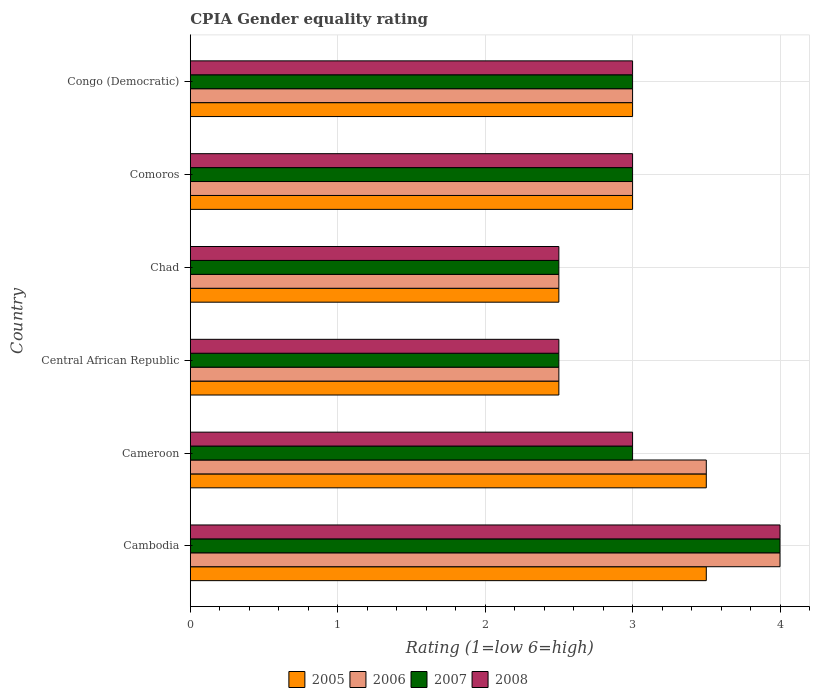How many different coloured bars are there?
Keep it short and to the point. 4. Are the number of bars on each tick of the Y-axis equal?
Make the answer very short. Yes. How many bars are there on the 4th tick from the top?
Ensure brevity in your answer.  4. What is the label of the 1st group of bars from the top?
Give a very brief answer. Congo (Democratic). In how many cases, is the number of bars for a given country not equal to the number of legend labels?
Give a very brief answer. 0. What is the CPIA rating in 2008 in Central African Republic?
Offer a very short reply. 2.5. Across all countries, what is the maximum CPIA rating in 2006?
Offer a very short reply. 4. In which country was the CPIA rating in 2007 maximum?
Provide a succinct answer. Cambodia. In which country was the CPIA rating in 2007 minimum?
Your response must be concise. Central African Republic. What is the total CPIA rating in 2006 in the graph?
Offer a very short reply. 18.5. What is the average CPIA rating in 2007 per country?
Provide a succinct answer. 3. What is the ratio of the CPIA rating in 2005 in Cambodia to that in Central African Republic?
Make the answer very short. 1.4. Is the difference between the CPIA rating in 2006 in Cambodia and Congo (Democratic) greater than the difference between the CPIA rating in 2005 in Cambodia and Congo (Democratic)?
Your answer should be compact. Yes. What is the difference between the highest and the second highest CPIA rating in 2005?
Ensure brevity in your answer.  0. What is the difference between the highest and the lowest CPIA rating in 2006?
Ensure brevity in your answer.  1.5. In how many countries, is the CPIA rating in 2005 greater than the average CPIA rating in 2005 taken over all countries?
Offer a terse response. 2. Is it the case that in every country, the sum of the CPIA rating in 2008 and CPIA rating in 2005 is greater than the CPIA rating in 2007?
Make the answer very short. Yes. How many bars are there?
Offer a terse response. 24. Are all the bars in the graph horizontal?
Offer a terse response. Yes. Are the values on the major ticks of X-axis written in scientific E-notation?
Ensure brevity in your answer.  No. Does the graph contain grids?
Your answer should be very brief. Yes. Where does the legend appear in the graph?
Make the answer very short. Bottom center. What is the title of the graph?
Offer a terse response. CPIA Gender equality rating. What is the label or title of the X-axis?
Your answer should be very brief. Rating (1=low 6=high). What is the label or title of the Y-axis?
Provide a succinct answer. Country. What is the Rating (1=low 6=high) of 2007 in Cambodia?
Your response must be concise. 4. What is the Rating (1=low 6=high) of 2008 in Cambodia?
Ensure brevity in your answer.  4. What is the Rating (1=low 6=high) of 2005 in Cameroon?
Provide a succinct answer. 3.5. What is the Rating (1=low 6=high) of 2008 in Cameroon?
Make the answer very short. 3. What is the Rating (1=low 6=high) of 2005 in Central African Republic?
Provide a short and direct response. 2.5. What is the Rating (1=low 6=high) of 2006 in Central African Republic?
Your answer should be compact. 2.5. What is the Rating (1=low 6=high) in 2005 in Chad?
Your answer should be compact. 2.5. What is the Rating (1=low 6=high) in 2008 in Chad?
Offer a terse response. 2.5. What is the Rating (1=low 6=high) of 2006 in Comoros?
Offer a terse response. 3. What is the Rating (1=low 6=high) of 2008 in Comoros?
Offer a very short reply. 3. What is the Rating (1=low 6=high) in 2005 in Congo (Democratic)?
Your response must be concise. 3. What is the Rating (1=low 6=high) in 2007 in Congo (Democratic)?
Ensure brevity in your answer.  3. What is the Rating (1=low 6=high) in 2008 in Congo (Democratic)?
Your response must be concise. 3. Across all countries, what is the maximum Rating (1=low 6=high) in 2005?
Make the answer very short. 3.5. Across all countries, what is the maximum Rating (1=low 6=high) in 2007?
Keep it short and to the point. 4. Across all countries, what is the maximum Rating (1=low 6=high) in 2008?
Your answer should be very brief. 4. Across all countries, what is the minimum Rating (1=low 6=high) of 2005?
Offer a very short reply. 2.5. Across all countries, what is the minimum Rating (1=low 6=high) of 2007?
Ensure brevity in your answer.  2.5. Across all countries, what is the minimum Rating (1=low 6=high) of 2008?
Your response must be concise. 2.5. What is the total Rating (1=low 6=high) of 2005 in the graph?
Your answer should be very brief. 18. What is the difference between the Rating (1=low 6=high) of 2006 in Cambodia and that in Cameroon?
Offer a terse response. 0.5. What is the difference between the Rating (1=low 6=high) of 2007 in Cambodia and that in Cameroon?
Provide a short and direct response. 1. What is the difference between the Rating (1=low 6=high) in 2008 in Cambodia and that in Cameroon?
Your answer should be compact. 1. What is the difference between the Rating (1=low 6=high) in 2005 in Cambodia and that in Central African Republic?
Your answer should be compact. 1. What is the difference between the Rating (1=low 6=high) of 2006 in Cambodia and that in Central African Republic?
Provide a succinct answer. 1.5. What is the difference between the Rating (1=low 6=high) of 2006 in Cambodia and that in Chad?
Provide a short and direct response. 1.5. What is the difference between the Rating (1=low 6=high) in 2007 in Cambodia and that in Chad?
Your response must be concise. 1.5. What is the difference between the Rating (1=low 6=high) in 2005 in Cambodia and that in Comoros?
Provide a succinct answer. 0.5. What is the difference between the Rating (1=low 6=high) of 2006 in Cambodia and that in Comoros?
Provide a succinct answer. 1. What is the difference between the Rating (1=low 6=high) of 2008 in Cambodia and that in Comoros?
Give a very brief answer. 1. What is the difference between the Rating (1=low 6=high) in 2007 in Cambodia and that in Congo (Democratic)?
Offer a very short reply. 1. What is the difference between the Rating (1=low 6=high) in 2005 in Cameroon and that in Chad?
Your answer should be very brief. 1. What is the difference between the Rating (1=low 6=high) in 2006 in Cameroon and that in Chad?
Offer a terse response. 1. What is the difference between the Rating (1=low 6=high) in 2007 in Cameroon and that in Chad?
Your response must be concise. 0.5. What is the difference between the Rating (1=low 6=high) in 2008 in Cameroon and that in Chad?
Your response must be concise. 0.5. What is the difference between the Rating (1=low 6=high) in 2006 in Cameroon and that in Comoros?
Make the answer very short. 0.5. What is the difference between the Rating (1=low 6=high) of 2005 in Cameroon and that in Congo (Democratic)?
Offer a terse response. 0.5. What is the difference between the Rating (1=low 6=high) of 2006 in Cameroon and that in Congo (Democratic)?
Your answer should be very brief. 0.5. What is the difference between the Rating (1=low 6=high) of 2007 in Cameroon and that in Congo (Democratic)?
Give a very brief answer. 0. What is the difference between the Rating (1=low 6=high) in 2008 in Cameroon and that in Congo (Democratic)?
Your answer should be very brief. 0. What is the difference between the Rating (1=low 6=high) of 2006 in Central African Republic and that in Chad?
Your answer should be very brief. 0. What is the difference between the Rating (1=low 6=high) in 2007 in Central African Republic and that in Chad?
Your answer should be very brief. 0. What is the difference between the Rating (1=low 6=high) of 2006 in Central African Republic and that in Comoros?
Offer a very short reply. -0.5. What is the difference between the Rating (1=low 6=high) of 2007 in Central African Republic and that in Comoros?
Give a very brief answer. -0.5. What is the difference between the Rating (1=low 6=high) of 2008 in Central African Republic and that in Comoros?
Offer a very short reply. -0.5. What is the difference between the Rating (1=low 6=high) in 2005 in Central African Republic and that in Congo (Democratic)?
Offer a terse response. -0.5. What is the difference between the Rating (1=low 6=high) in 2006 in Central African Republic and that in Congo (Democratic)?
Give a very brief answer. -0.5. What is the difference between the Rating (1=low 6=high) of 2007 in Central African Republic and that in Congo (Democratic)?
Your answer should be very brief. -0.5. What is the difference between the Rating (1=low 6=high) of 2007 in Chad and that in Comoros?
Make the answer very short. -0.5. What is the difference between the Rating (1=low 6=high) of 2005 in Comoros and that in Congo (Democratic)?
Ensure brevity in your answer.  0. What is the difference between the Rating (1=low 6=high) in 2006 in Comoros and that in Congo (Democratic)?
Offer a very short reply. 0. What is the difference between the Rating (1=low 6=high) of 2007 in Comoros and that in Congo (Democratic)?
Ensure brevity in your answer.  0. What is the difference between the Rating (1=low 6=high) of 2008 in Comoros and that in Congo (Democratic)?
Keep it short and to the point. 0. What is the difference between the Rating (1=low 6=high) of 2005 in Cambodia and the Rating (1=low 6=high) of 2006 in Cameroon?
Your answer should be very brief. 0. What is the difference between the Rating (1=low 6=high) of 2005 in Cambodia and the Rating (1=low 6=high) of 2007 in Cameroon?
Ensure brevity in your answer.  0.5. What is the difference between the Rating (1=low 6=high) in 2005 in Cambodia and the Rating (1=low 6=high) in 2008 in Cameroon?
Your response must be concise. 0.5. What is the difference between the Rating (1=low 6=high) in 2006 in Cambodia and the Rating (1=low 6=high) in 2007 in Cameroon?
Make the answer very short. 1. What is the difference between the Rating (1=low 6=high) of 2006 in Cambodia and the Rating (1=low 6=high) of 2008 in Cameroon?
Ensure brevity in your answer.  1. What is the difference between the Rating (1=low 6=high) in 2005 in Cambodia and the Rating (1=low 6=high) in 2006 in Central African Republic?
Your answer should be compact. 1. What is the difference between the Rating (1=low 6=high) of 2005 in Cambodia and the Rating (1=low 6=high) of 2007 in Chad?
Make the answer very short. 1. What is the difference between the Rating (1=low 6=high) of 2005 in Cambodia and the Rating (1=low 6=high) of 2008 in Chad?
Your answer should be compact. 1. What is the difference between the Rating (1=low 6=high) of 2006 in Cambodia and the Rating (1=low 6=high) of 2007 in Chad?
Keep it short and to the point. 1.5. What is the difference between the Rating (1=low 6=high) in 2007 in Cambodia and the Rating (1=low 6=high) in 2008 in Chad?
Offer a terse response. 1.5. What is the difference between the Rating (1=low 6=high) in 2005 in Cambodia and the Rating (1=low 6=high) in 2006 in Comoros?
Offer a terse response. 0.5. What is the difference between the Rating (1=low 6=high) of 2005 in Cambodia and the Rating (1=low 6=high) of 2008 in Comoros?
Provide a short and direct response. 0.5. What is the difference between the Rating (1=low 6=high) of 2005 in Cambodia and the Rating (1=low 6=high) of 2006 in Congo (Democratic)?
Keep it short and to the point. 0.5. What is the difference between the Rating (1=low 6=high) in 2005 in Cambodia and the Rating (1=low 6=high) in 2007 in Congo (Democratic)?
Your answer should be very brief. 0.5. What is the difference between the Rating (1=low 6=high) in 2006 in Cambodia and the Rating (1=low 6=high) in 2008 in Congo (Democratic)?
Provide a short and direct response. 1. What is the difference between the Rating (1=low 6=high) in 2005 in Cameroon and the Rating (1=low 6=high) in 2006 in Central African Republic?
Offer a very short reply. 1. What is the difference between the Rating (1=low 6=high) in 2005 in Cameroon and the Rating (1=low 6=high) in 2007 in Central African Republic?
Provide a short and direct response. 1. What is the difference between the Rating (1=low 6=high) of 2005 in Cameroon and the Rating (1=low 6=high) of 2008 in Central African Republic?
Ensure brevity in your answer.  1. What is the difference between the Rating (1=low 6=high) of 2005 in Cameroon and the Rating (1=low 6=high) of 2007 in Chad?
Make the answer very short. 1. What is the difference between the Rating (1=low 6=high) in 2006 in Cameroon and the Rating (1=low 6=high) in 2008 in Chad?
Offer a terse response. 1. What is the difference between the Rating (1=low 6=high) of 2007 in Cameroon and the Rating (1=low 6=high) of 2008 in Chad?
Ensure brevity in your answer.  0.5. What is the difference between the Rating (1=low 6=high) of 2005 in Cameroon and the Rating (1=low 6=high) of 2006 in Comoros?
Offer a very short reply. 0.5. What is the difference between the Rating (1=low 6=high) in 2005 in Cameroon and the Rating (1=low 6=high) in 2008 in Comoros?
Make the answer very short. 0.5. What is the difference between the Rating (1=low 6=high) in 2006 in Cameroon and the Rating (1=low 6=high) in 2007 in Comoros?
Give a very brief answer. 0.5. What is the difference between the Rating (1=low 6=high) of 2006 in Cameroon and the Rating (1=low 6=high) of 2008 in Comoros?
Give a very brief answer. 0.5. What is the difference between the Rating (1=low 6=high) of 2007 in Cameroon and the Rating (1=low 6=high) of 2008 in Comoros?
Provide a short and direct response. 0. What is the difference between the Rating (1=low 6=high) of 2005 in Cameroon and the Rating (1=low 6=high) of 2006 in Congo (Democratic)?
Your answer should be very brief. 0.5. What is the difference between the Rating (1=low 6=high) in 2005 in Cameroon and the Rating (1=low 6=high) in 2008 in Congo (Democratic)?
Your answer should be very brief. 0.5. What is the difference between the Rating (1=low 6=high) in 2005 in Central African Republic and the Rating (1=low 6=high) in 2008 in Chad?
Ensure brevity in your answer.  0. What is the difference between the Rating (1=low 6=high) of 2006 in Central African Republic and the Rating (1=low 6=high) of 2007 in Chad?
Give a very brief answer. 0. What is the difference between the Rating (1=low 6=high) of 2007 in Central African Republic and the Rating (1=low 6=high) of 2008 in Chad?
Your answer should be very brief. 0. What is the difference between the Rating (1=low 6=high) in 2005 in Central African Republic and the Rating (1=low 6=high) in 2006 in Comoros?
Your answer should be very brief. -0.5. What is the difference between the Rating (1=low 6=high) in 2005 in Central African Republic and the Rating (1=low 6=high) in 2007 in Comoros?
Offer a very short reply. -0.5. What is the difference between the Rating (1=low 6=high) in 2006 in Central African Republic and the Rating (1=low 6=high) in 2008 in Comoros?
Give a very brief answer. -0.5. What is the difference between the Rating (1=low 6=high) of 2007 in Central African Republic and the Rating (1=low 6=high) of 2008 in Comoros?
Give a very brief answer. -0.5. What is the difference between the Rating (1=low 6=high) of 2005 in Central African Republic and the Rating (1=low 6=high) of 2006 in Congo (Democratic)?
Keep it short and to the point. -0.5. What is the difference between the Rating (1=low 6=high) of 2006 in Central African Republic and the Rating (1=low 6=high) of 2007 in Congo (Democratic)?
Provide a short and direct response. -0.5. What is the difference between the Rating (1=low 6=high) of 2006 in Central African Republic and the Rating (1=low 6=high) of 2008 in Congo (Democratic)?
Provide a short and direct response. -0.5. What is the difference between the Rating (1=low 6=high) in 2005 in Chad and the Rating (1=low 6=high) in 2006 in Comoros?
Ensure brevity in your answer.  -0.5. What is the difference between the Rating (1=low 6=high) in 2005 in Chad and the Rating (1=low 6=high) in 2008 in Comoros?
Your answer should be very brief. -0.5. What is the difference between the Rating (1=low 6=high) in 2006 in Chad and the Rating (1=low 6=high) in 2008 in Comoros?
Your answer should be compact. -0.5. What is the difference between the Rating (1=low 6=high) of 2007 in Chad and the Rating (1=low 6=high) of 2008 in Congo (Democratic)?
Ensure brevity in your answer.  -0.5. What is the difference between the Rating (1=low 6=high) in 2005 in Comoros and the Rating (1=low 6=high) in 2007 in Congo (Democratic)?
Provide a short and direct response. 0. What is the difference between the Rating (1=low 6=high) of 2005 in Comoros and the Rating (1=low 6=high) of 2008 in Congo (Democratic)?
Provide a short and direct response. 0. What is the difference between the Rating (1=low 6=high) of 2006 in Comoros and the Rating (1=low 6=high) of 2007 in Congo (Democratic)?
Keep it short and to the point. 0. What is the difference between the Rating (1=low 6=high) of 2007 in Comoros and the Rating (1=low 6=high) of 2008 in Congo (Democratic)?
Your answer should be very brief. 0. What is the average Rating (1=low 6=high) in 2005 per country?
Provide a succinct answer. 3. What is the average Rating (1=low 6=high) in 2006 per country?
Provide a succinct answer. 3.08. What is the average Rating (1=low 6=high) of 2007 per country?
Keep it short and to the point. 3. What is the difference between the Rating (1=low 6=high) in 2005 and Rating (1=low 6=high) in 2006 in Cambodia?
Provide a succinct answer. -0.5. What is the difference between the Rating (1=low 6=high) of 2005 and Rating (1=low 6=high) of 2007 in Cambodia?
Your answer should be compact. -0.5. What is the difference between the Rating (1=low 6=high) in 2005 and Rating (1=low 6=high) in 2008 in Cambodia?
Ensure brevity in your answer.  -0.5. What is the difference between the Rating (1=low 6=high) of 2006 and Rating (1=low 6=high) of 2007 in Cambodia?
Your response must be concise. 0. What is the difference between the Rating (1=low 6=high) of 2006 and Rating (1=low 6=high) of 2008 in Cambodia?
Keep it short and to the point. 0. What is the difference between the Rating (1=low 6=high) of 2007 and Rating (1=low 6=high) of 2008 in Cambodia?
Offer a terse response. 0. What is the difference between the Rating (1=low 6=high) of 2005 and Rating (1=low 6=high) of 2008 in Cameroon?
Keep it short and to the point. 0.5. What is the difference between the Rating (1=low 6=high) of 2006 and Rating (1=low 6=high) of 2008 in Cameroon?
Offer a very short reply. 0.5. What is the difference between the Rating (1=low 6=high) in 2007 and Rating (1=low 6=high) in 2008 in Cameroon?
Give a very brief answer. 0. What is the difference between the Rating (1=low 6=high) in 2005 and Rating (1=low 6=high) in 2008 in Central African Republic?
Your answer should be compact. 0. What is the difference between the Rating (1=low 6=high) of 2006 and Rating (1=low 6=high) of 2007 in Central African Republic?
Keep it short and to the point. 0. What is the difference between the Rating (1=low 6=high) of 2005 and Rating (1=low 6=high) of 2008 in Chad?
Provide a succinct answer. 0. What is the difference between the Rating (1=low 6=high) in 2006 and Rating (1=low 6=high) in 2007 in Chad?
Your answer should be very brief. 0. What is the difference between the Rating (1=low 6=high) of 2006 and Rating (1=low 6=high) of 2008 in Chad?
Offer a terse response. 0. What is the difference between the Rating (1=low 6=high) of 2007 and Rating (1=low 6=high) of 2008 in Chad?
Your answer should be very brief. 0. What is the difference between the Rating (1=low 6=high) in 2005 and Rating (1=low 6=high) in 2007 in Comoros?
Offer a very short reply. 0. What is the difference between the Rating (1=low 6=high) in 2006 and Rating (1=low 6=high) in 2008 in Comoros?
Your answer should be compact. 0. What is the difference between the Rating (1=low 6=high) in 2005 and Rating (1=low 6=high) in 2007 in Congo (Democratic)?
Offer a terse response. 0. What is the difference between the Rating (1=low 6=high) of 2005 and Rating (1=low 6=high) of 2008 in Congo (Democratic)?
Ensure brevity in your answer.  0. What is the difference between the Rating (1=low 6=high) of 2006 and Rating (1=low 6=high) of 2007 in Congo (Democratic)?
Keep it short and to the point. 0. What is the difference between the Rating (1=low 6=high) of 2006 and Rating (1=low 6=high) of 2008 in Congo (Democratic)?
Your answer should be compact. 0. What is the ratio of the Rating (1=low 6=high) of 2005 in Cambodia to that in Cameroon?
Make the answer very short. 1. What is the ratio of the Rating (1=low 6=high) of 2008 in Cambodia to that in Cameroon?
Your response must be concise. 1.33. What is the ratio of the Rating (1=low 6=high) in 2008 in Cambodia to that in Central African Republic?
Offer a terse response. 1.6. What is the ratio of the Rating (1=low 6=high) in 2005 in Cambodia to that in Chad?
Offer a very short reply. 1.4. What is the ratio of the Rating (1=low 6=high) in 2006 in Cambodia to that in Chad?
Your response must be concise. 1.6. What is the ratio of the Rating (1=low 6=high) of 2007 in Cambodia to that in Chad?
Make the answer very short. 1.6. What is the ratio of the Rating (1=low 6=high) in 2008 in Cambodia to that in Comoros?
Make the answer very short. 1.33. What is the ratio of the Rating (1=low 6=high) of 2006 in Cambodia to that in Congo (Democratic)?
Your response must be concise. 1.33. What is the ratio of the Rating (1=low 6=high) in 2007 in Cambodia to that in Congo (Democratic)?
Provide a succinct answer. 1.33. What is the ratio of the Rating (1=low 6=high) of 2006 in Cameroon to that in Central African Republic?
Ensure brevity in your answer.  1.4. What is the ratio of the Rating (1=low 6=high) of 2007 in Cameroon to that in Central African Republic?
Your answer should be very brief. 1.2. What is the ratio of the Rating (1=low 6=high) in 2006 in Cameroon to that in Chad?
Keep it short and to the point. 1.4. What is the ratio of the Rating (1=low 6=high) of 2008 in Cameroon to that in Chad?
Keep it short and to the point. 1.2. What is the ratio of the Rating (1=low 6=high) in 2005 in Cameroon to that in Comoros?
Provide a succinct answer. 1.17. What is the ratio of the Rating (1=low 6=high) in 2007 in Cameroon to that in Comoros?
Ensure brevity in your answer.  1. What is the ratio of the Rating (1=low 6=high) of 2006 in Cameroon to that in Congo (Democratic)?
Give a very brief answer. 1.17. What is the ratio of the Rating (1=low 6=high) in 2007 in Cameroon to that in Congo (Democratic)?
Your answer should be compact. 1. What is the ratio of the Rating (1=low 6=high) of 2008 in Cameroon to that in Congo (Democratic)?
Make the answer very short. 1. What is the ratio of the Rating (1=low 6=high) of 2005 in Central African Republic to that in Chad?
Offer a terse response. 1. What is the ratio of the Rating (1=low 6=high) of 2006 in Central African Republic to that in Chad?
Keep it short and to the point. 1. What is the ratio of the Rating (1=low 6=high) of 2008 in Central African Republic to that in Chad?
Ensure brevity in your answer.  1. What is the ratio of the Rating (1=low 6=high) of 2005 in Central African Republic to that in Comoros?
Your answer should be very brief. 0.83. What is the ratio of the Rating (1=low 6=high) in 2006 in Central African Republic to that in Comoros?
Provide a succinct answer. 0.83. What is the ratio of the Rating (1=low 6=high) of 2008 in Central African Republic to that in Comoros?
Your answer should be compact. 0.83. What is the ratio of the Rating (1=low 6=high) in 2008 in Chad to that in Comoros?
Keep it short and to the point. 0.83. What is the ratio of the Rating (1=low 6=high) of 2005 in Chad to that in Congo (Democratic)?
Offer a terse response. 0.83. What is the ratio of the Rating (1=low 6=high) of 2008 in Chad to that in Congo (Democratic)?
Make the answer very short. 0.83. What is the ratio of the Rating (1=low 6=high) of 2005 in Comoros to that in Congo (Democratic)?
Keep it short and to the point. 1. What is the ratio of the Rating (1=low 6=high) in 2006 in Comoros to that in Congo (Democratic)?
Your response must be concise. 1. What is the ratio of the Rating (1=low 6=high) in 2007 in Comoros to that in Congo (Democratic)?
Provide a succinct answer. 1. What is the difference between the highest and the second highest Rating (1=low 6=high) of 2007?
Provide a short and direct response. 1. What is the difference between the highest and the second highest Rating (1=low 6=high) in 2008?
Provide a succinct answer. 1. What is the difference between the highest and the lowest Rating (1=low 6=high) of 2007?
Give a very brief answer. 1.5. 